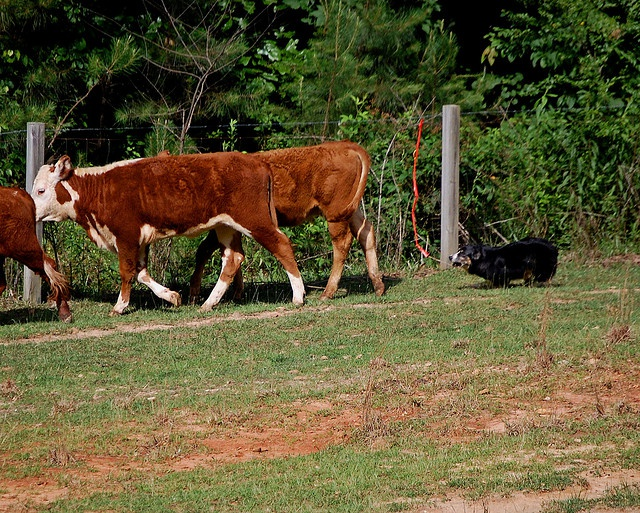Describe the objects in this image and their specific colors. I can see cow in olive, maroon, black, and brown tones, cow in olive, brown, maroon, and black tones, cow in olive, maroon, black, and gray tones, and dog in olive, black, gray, and darkgreen tones in this image. 